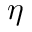Convert formula to latex. <formula><loc_0><loc_0><loc_500><loc_500>\eta</formula> 